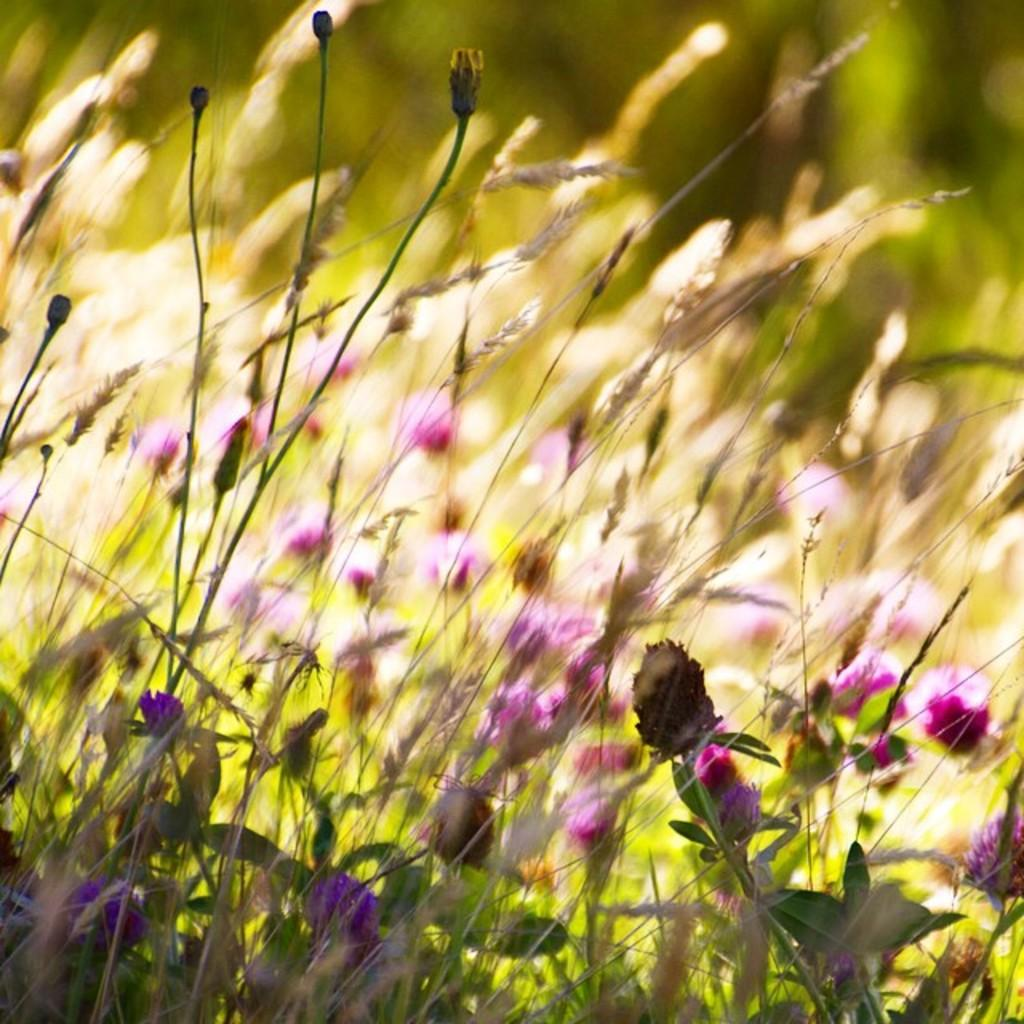What type of plants can be seen in the image? There are flower plants in the image. Can you describe the background of the image? The background of the image is blurred. What types of toys are being played with by the fowl in the image? There are no toys or fowl present in the image; it features flower plants and a blurred background. 